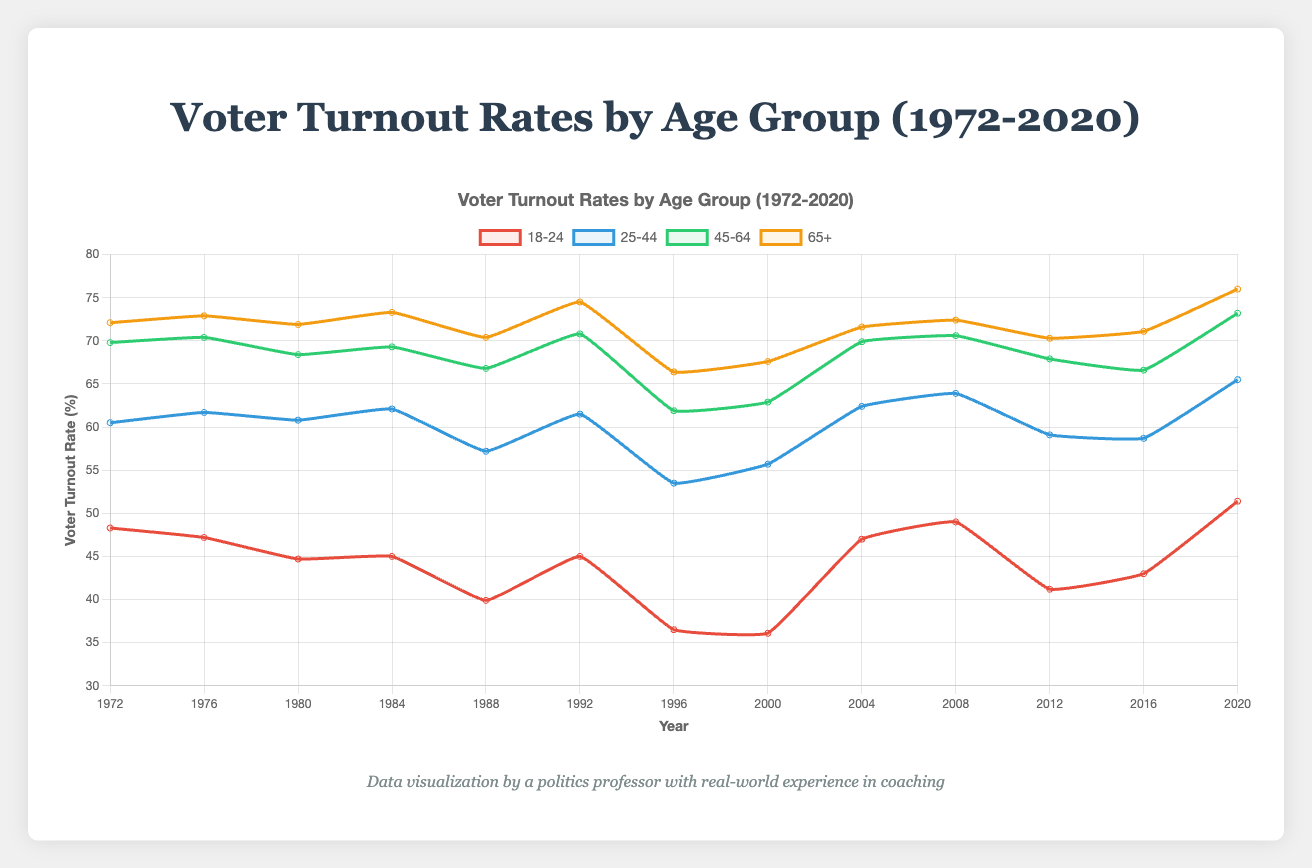Which age group had the highest voter turnout rate in 2020? In the plot, the age group with the highest line at the year 2020 indicates the highest voter turnout rate. For 2020, the line for the age group 65+ is at the top.
Answer: Age65Plus Which year shows the lowest voter turnout rate for the 18-24 age group? To find this, look for the lowest point on the 18-24 line. The lowest point for 18-24 occurs in 1996.
Answer: 1996 How does the voter turnout rate for age 25-44 in 1988 compare to that in 2000? In 1988, the turnout for age 25-44 is 57.2%. In 2000, it's 55.7%. Compare these values to see that it decreased slightly by 1.5%.
Answer: Decreased by 1.5% In which year did the voter turnout rate for age 65+ first reach 74%? Scan the 65+ line to see where it first meets or exceeds 74%. This happens in the year 1992.
Answer: 1992 What is the overall trend in voter turnout rates for the age group 45-64 from 1972 to 2020? The 45-64 line overall shows a slight increase in voter turnouts from 69.8% in 1972 to 73.2% in 2020, despite some fluctuations.
Answer: Slight increase Which age group generally has the lowest voter turnout rate throughout the period? Compare the lines for all age groups over the entire period. The 18-24 line is consistently the lowest.
Answer: Age18_24 Which two years show the greatest increase in voter turnout rate for the age group 18-24? Examine the 18-24 line to find the greatest slope between two consecutive years. The steepest incline is between 1996 and 2004, where the rate jumps from 36.5% to 47.0%.
Answer: 1996 and 2004 What is the difference in voter turnout rates between the age groups 18-24 and 65+ in 1972? Check the voter turnout rate for each group in 1972: 48.3% for 18-24 and 72.1% for 65+. The difference is 72.1% - 48.3% = 23.8%.
Answer: 23.8% Which age group experienced the most consistent voter turnout rates (least variation) over the entire period? Observe the variability of the lines. The 65+ group has relatively minor fluctuations, indicating the least variation.
Answer: Age65Plus During which decade did the age group 45-64 experience the most decline in voter turnout rates? Look at each decade for the 45-64 line to find the greatest downward trend. The most significant decline occurs from 1992 (70.8%) to 1996 (61.9%), indicating the 1990s.
Answer: 1990s 